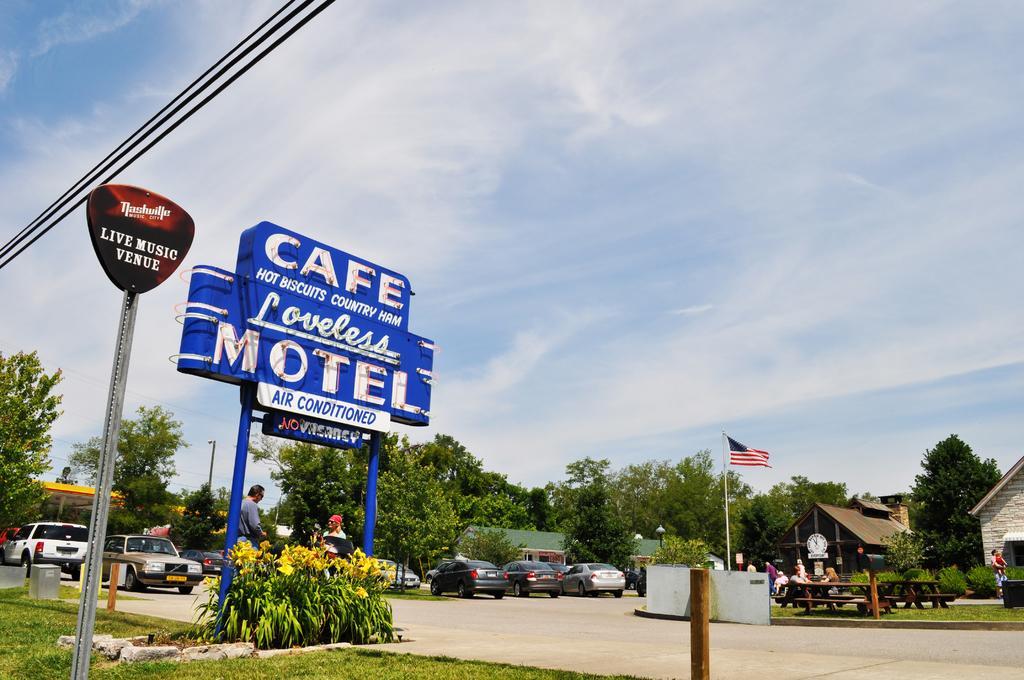Please provide a concise description of this image. On the left side, there are cables. Below these cables, there are two hoardings attached to the poles, there are plants and grass on the ground. On the right side, there is a small pole on the ground. In the background, there is a flag, there are vehicles, there are buildings, trees, and grass on the ground and there are clouds in the sky. 